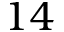<formula> <loc_0><loc_0><loc_500><loc_500>1 4</formula> 